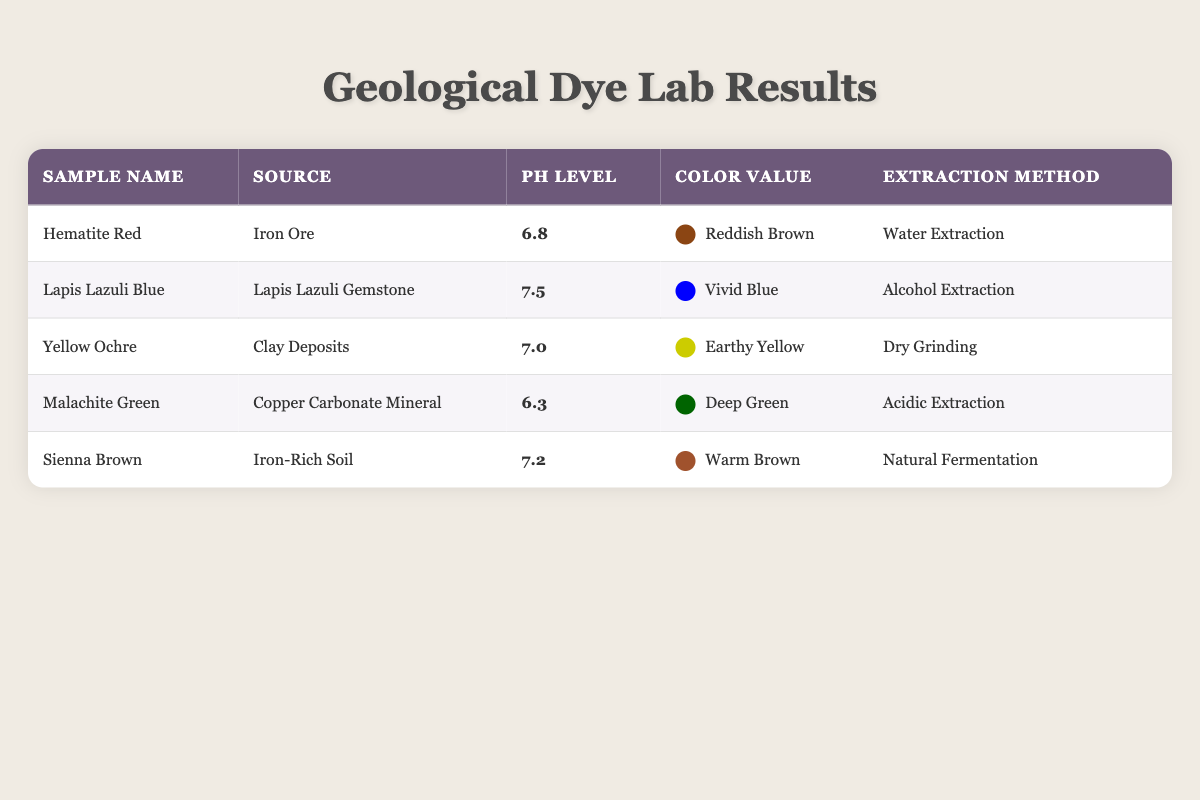What is the pH level of Lapis Lazuli Blue? The table shows that the pH level of Lapis Lazuli Blue is listed in the corresponding row under the pH Level column. It reads 7.5.
Answer: 7.5 Which sample has the highest pH level? By comparing all pH levels in the table, Lapis Lazuli Blue has the highest pH level of 7.5, against the others which are lower.
Answer: Lapis Lazuli Blue Is there a sample with a pH level below 7? Looking through the pH levels listed, Malachite Green has a pH level of 6.3, which is indeed below 7.
Answer: Yes What is the color value of the sample with the lowest pH level? The sample with the lowest pH level is Malachite Green, which has a pH of 6.3. The corresponding color value in the table is Deep Green.
Answer: Deep Green What is the average pH level of all samples? To find the average, add all the pH levels: (6.8 + 7.5 + 7.0 + 6.3 + 7.2) = 34.8. Divide by the number of samples (5): 34.8 / 5 = 6.96.
Answer: 6.96 How many samples have a pH level of 7 or higher? The samples with pH levels of 7 or higher are Lapis Lazuli Blue (7.5), Yellow Ochre (7.0), and Sienna Brown (7.2). Counting these gives a total of 3 samples.
Answer: 3 Which extraction method was used for Hematite Red? According to the table, the extraction method listed for Hematite Red is Water Extraction.
Answer: Water Extraction Do both samples from iron sources have the same pH level? The two samples from iron sources are Hematite Red with a pH of 6.8 and Sienna Brown with a pH of 7.2. Since these values differ, the answer is no.
Answer: No Which two samples have pH levels that average to 7.05? Hematite Red (6.8) and Sienna Brown (7.2) are the samples being compared. Their average is (6.8 + 7.2) / 2 = 7.05, confirming that these two samples meet the criteria.
Answer: Hematite Red and Sienna Brown 